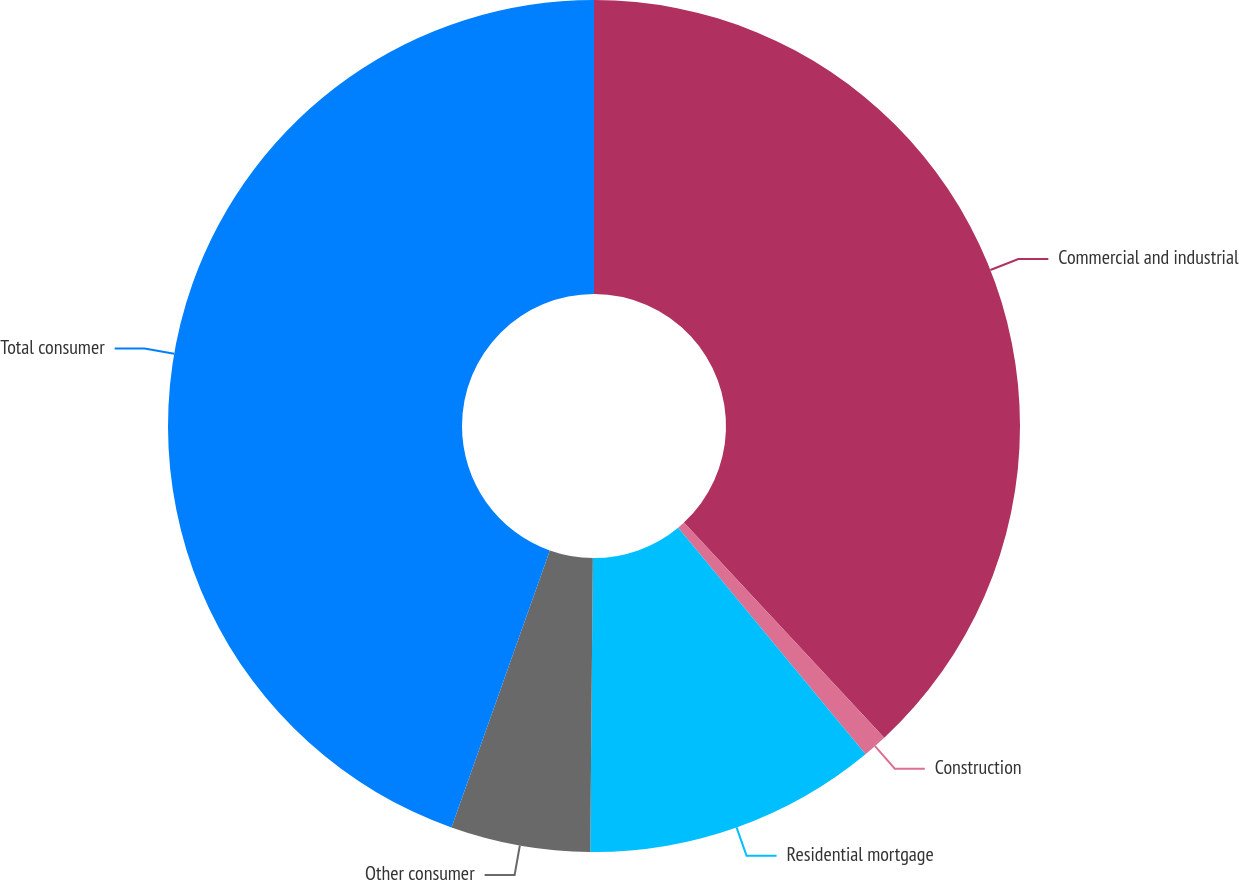<chart> <loc_0><loc_0><loc_500><loc_500><pie_chart><fcel>Commercial and industrial<fcel>Construction<fcel>Residential mortgage<fcel>Other consumer<fcel>Total consumer<nl><fcel>38.07%<fcel>0.93%<fcel>11.14%<fcel>5.29%<fcel>44.57%<nl></chart> 